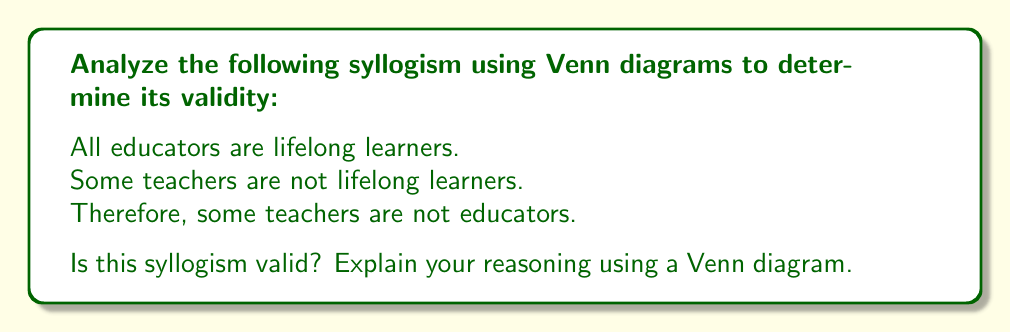Help me with this question. To determine the validity of this syllogism using Venn diagrams, let's follow these steps:

1. Identify the three sets involved:
   A: Educators
   B: Lifelong learners
   C: Teachers

2. Draw three overlapping circles to represent these sets:

[asy]
unitsize(1cm);
pair A = (0,0), B = (1,0), C = (0.5,0.866);
draw(circle(A,1));
draw(circle(B,1));
draw(circle(C,1));
label("A (Educators)", A, SW);
label("B (Lifelong learners)", B, SE);
label("C (Teachers)", C, N);
[/asy]

3. Represent the premises:

   Premise 1: All educators are lifelong learners.
   This means that circle A is entirely contained within circle B.

   Premise 2: Some teachers are not lifelong learners.
   This means that there must be an area in circle C that is outside of circle B.

4. Update the Venn diagram accordingly:

[asy]
unitsize(1cm);
pair A = (0,0), B = (1,0), C = (0.5,0.866);
draw(circle(A,1));
draw(circle(B,1));
draw(circle(C,1));
label("A (Educators)", A, SW);
label("B (Lifelong learners)", B, SE);
label("C (Teachers)", C, N);
fill(A--B--cycle, lightgray);
fill((0.5,0.866)--(1.3,0.5)--(1.3,1.2)--cycle, lightblue);
draw((0.9,0.7)--(1.1,0.9), blue+1);
draw((1.1,0.7)--(0.9,0.9), blue+1);
[/asy]

5. Analyze the conclusion:
   The conclusion states that "some teachers are not educators."
   In our Venn diagram, this would be represented by an area in circle C that is outside of circle A.

6. Evaluate the validity:
   From our Venn diagram, we can see that it's possible for there to be an area in circle C that is outside both circles A and B. This area represents teachers who are neither educators nor lifelong learners.

   However, the diagram does not necessarily require this area to exist. It's also possible for all teachers who are not lifelong learners to still be educators (represented by the area where C overlaps with A but not B).

Therefore, while the conclusion is possible based on the given premises, it is not necessarily true in all cases. This means the syllogism is not valid.
Answer: The syllogism is not valid. While the conclusion is possible based on the given premises, it does not necessarily follow from them in all cases. 